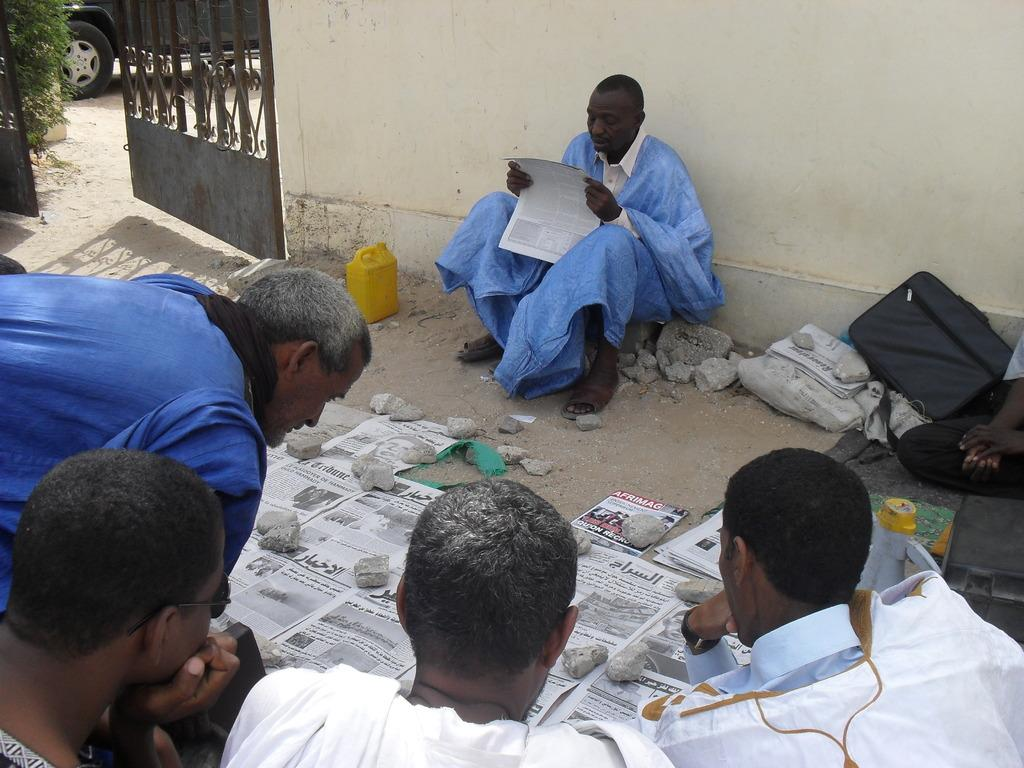How many people are in the image? There are people in the image, but the exact number is not specified. What is one person holding in the image? One person is holding a paper in the image. What else can be seen in the image besides people? There are papers, stones, bags, a gate, a vehicle, a plant, and a yellow object on the ground in the image. What type of soap is being used to clean the plant in the image? There is no soap or cleaning activity involving the plant in the image. 